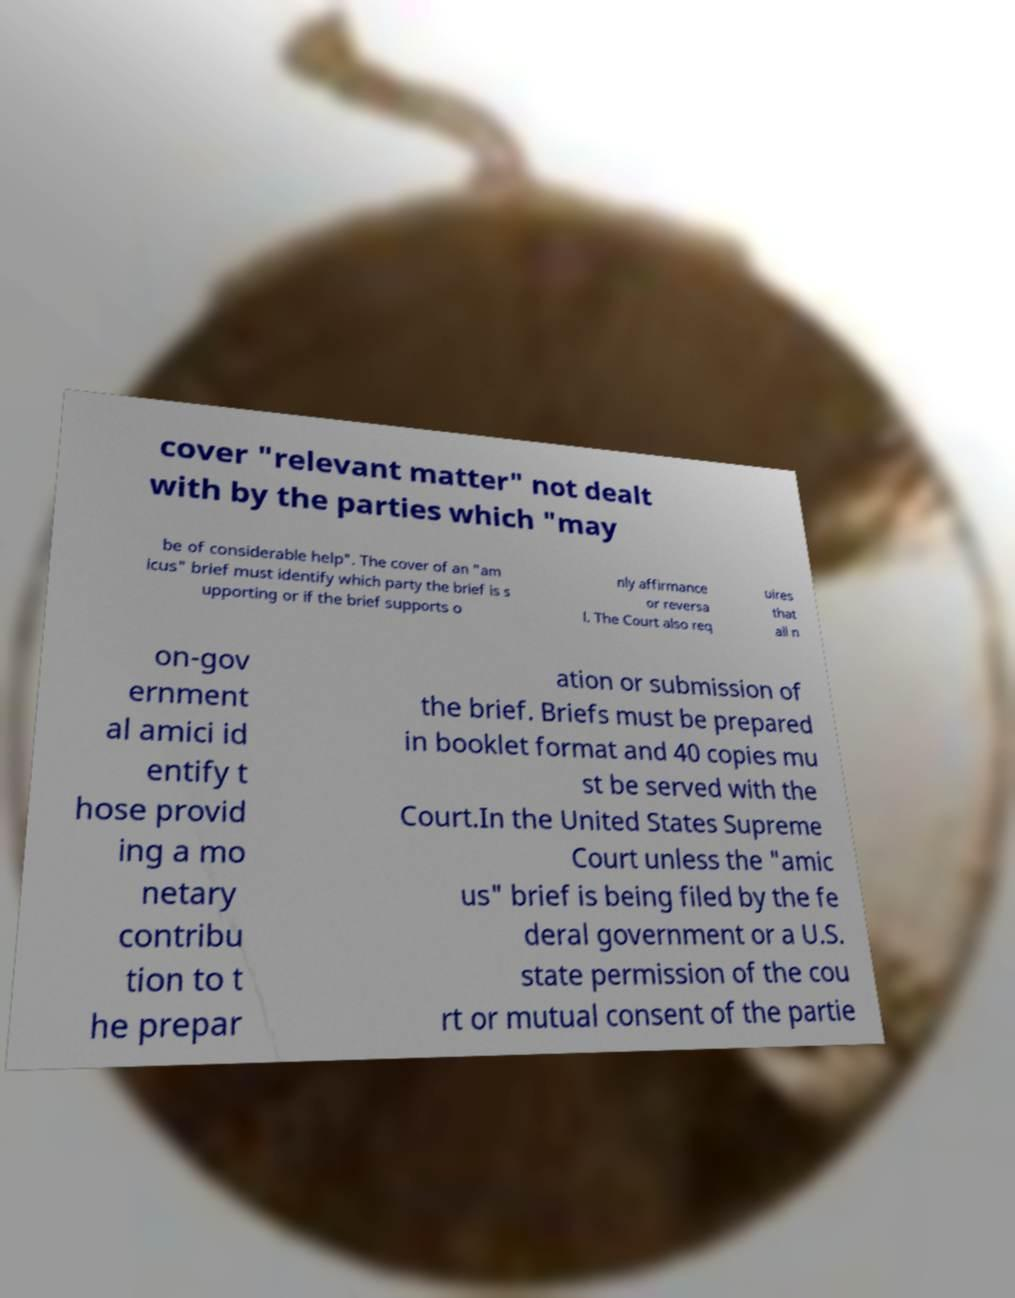Can you read and provide the text displayed in the image?This photo seems to have some interesting text. Can you extract and type it out for me? cover "relevant matter" not dealt with by the parties which "may be of considerable help". The cover of an "am icus" brief must identify which party the brief is s upporting or if the brief supports o nly affirmance or reversa l. The Court also req uires that all n on-gov ernment al amici id entify t hose provid ing a mo netary contribu tion to t he prepar ation or submission of the brief. Briefs must be prepared in booklet format and 40 copies mu st be served with the Court.In the United States Supreme Court unless the "amic us" brief is being filed by the fe deral government or a U.S. state permission of the cou rt or mutual consent of the partie 